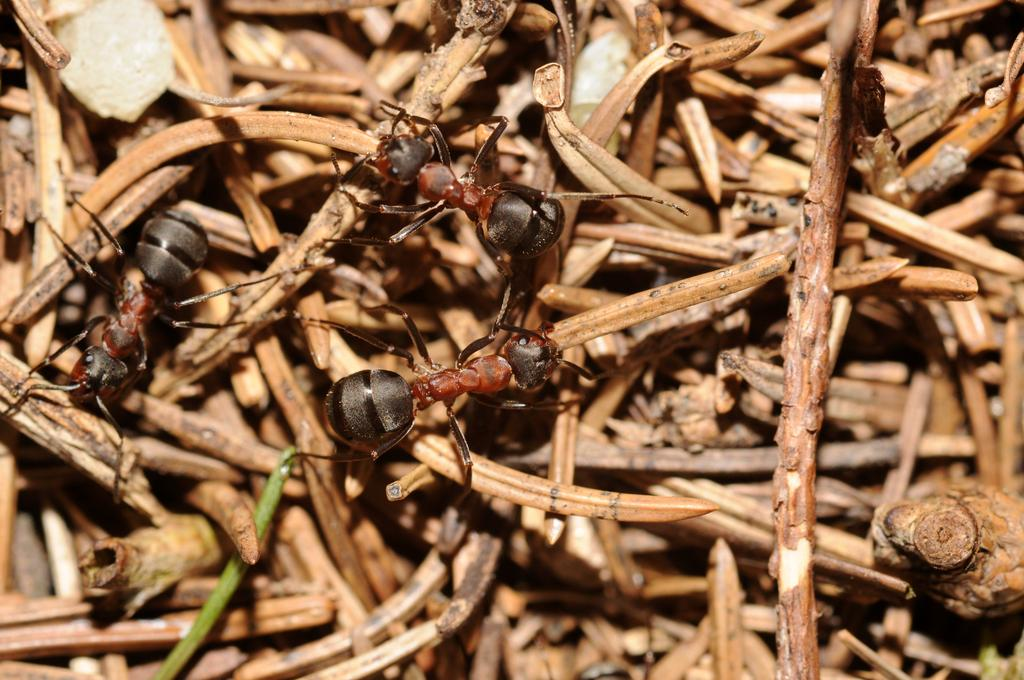How many ants can be seen in the image? There are three ants in the image. What can be found in the background of the image? There are small wooden sticks or twigs in the background of the image. What news is being reported by the snakes in the image? There are no snakes present in the image, so there is no news being reported. 